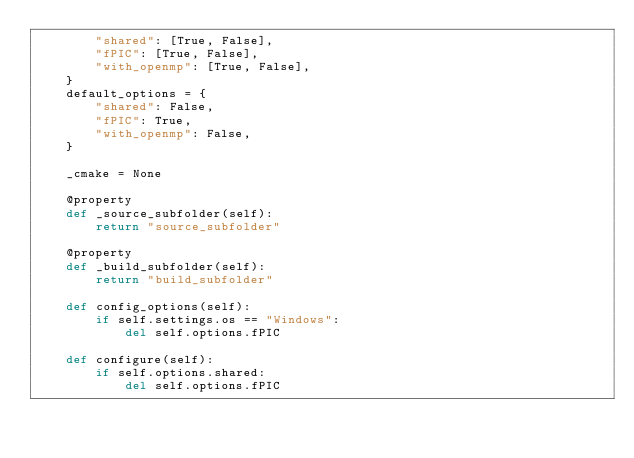Convert code to text. <code><loc_0><loc_0><loc_500><loc_500><_Python_>        "shared": [True, False],
        "fPIC": [True, False],
        "with_openmp": [True, False],
    }
    default_options = {
        "shared": False,
        "fPIC": True,
        "with_openmp": False,
    }

    _cmake = None

    @property
    def _source_subfolder(self):
        return "source_subfolder"

    @property
    def _build_subfolder(self):
        return "build_subfolder"

    def config_options(self):
        if self.settings.os == "Windows":
            del self.options.fPIC

    def configure(self):
        if self.options.shared:
            del self.options.fPIC</code> 